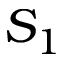<formula> <loc_0><loc_0><loc_500><loc_500>S _ { 1 }</formula> 